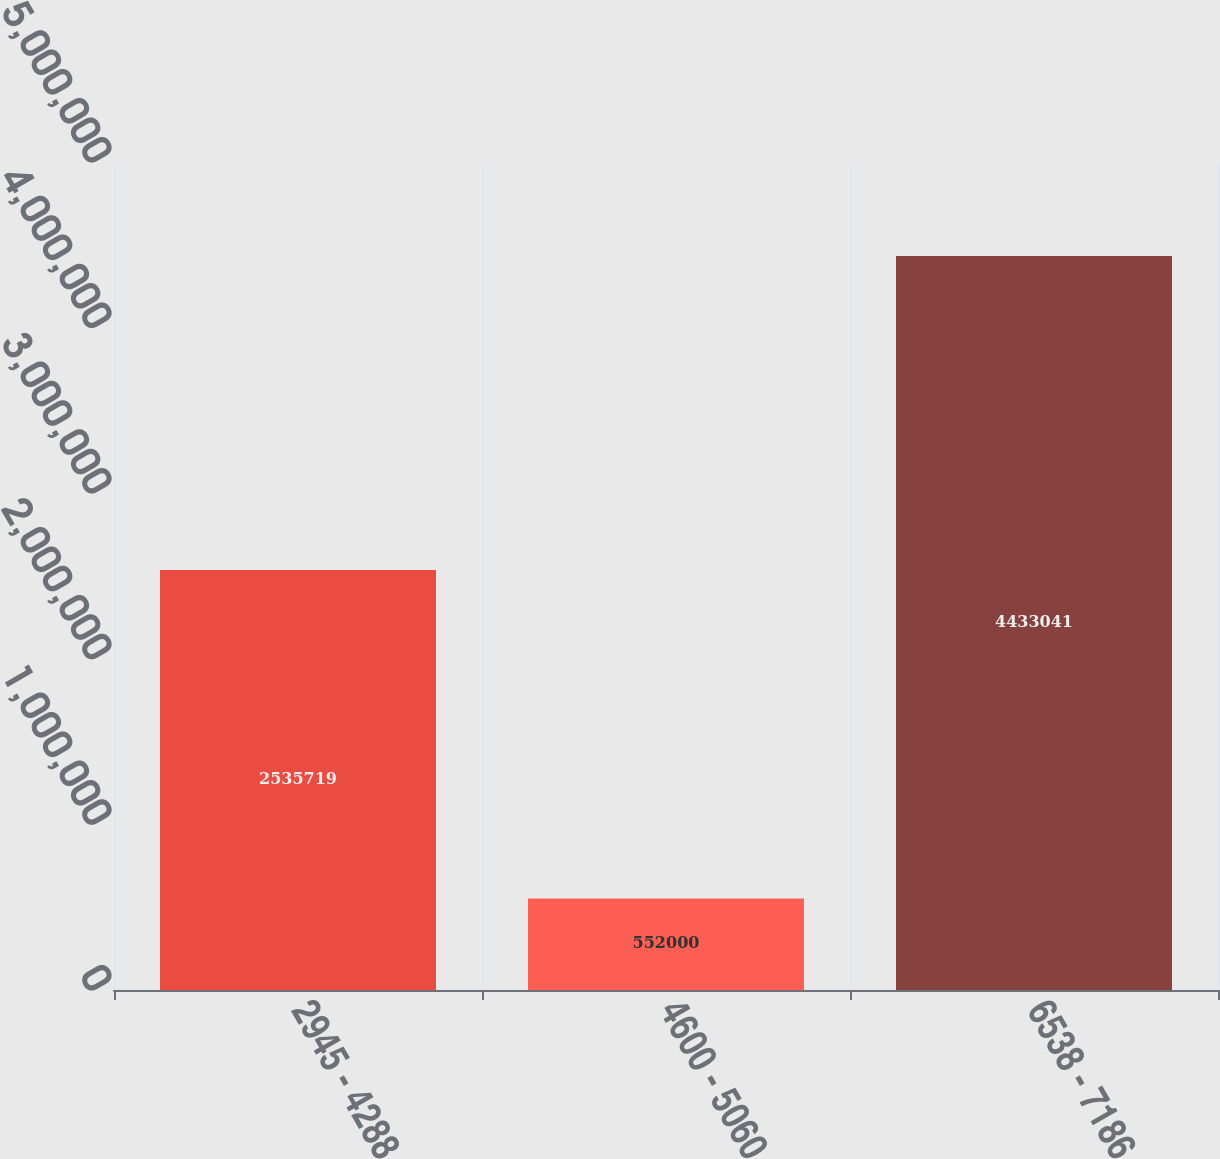Convert chart. <chart><loc_0><loc_0><loc_500><loc_500><bar_chart><fcel>2945 - 4288<fcel>4600 - 5060<fcel>6538 - 7186<nl><fcel>2.53572e+06<fcel>552000<fcel>4.43304e+06<nl></chart> 